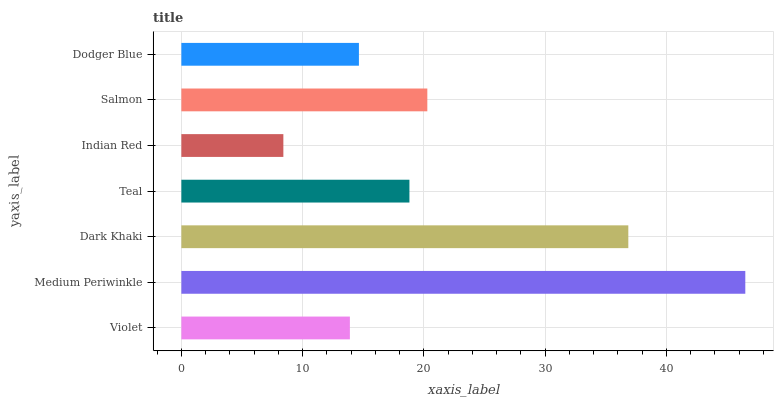Is Indian Red the minimum?
Answer yes or no. Yes. Is Medium Periwinkle the maximum?
Answer yes or no. Yes. Is Dark Khaki the minimum?
Answer yes or no. No. Is Dark Khaki the maximum?
Answer yes or no. No. Is Medium Periwinkle greater than Dark Khaki?
Answer yes or no. Yes. Is Dark Khaki less than Medium Periwinkle?
Answer yes or no. Yes. Is Dark Khaki greater than Medium Periwinkle?
Answer yes or no. No. Is Medium Periwinkle less than Dark Khaki?
Answer yes or no. No. Is Teal the high median?
Answer yes or no. Yes. Is Teal the low median?
Answer yes or no. Yes. Is Indian Red the high median?
Answer yes or no. No. Is Dodger Blue the low median?
Answer yes or no. No. 